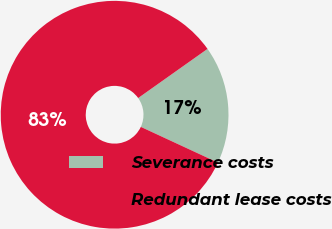Convert chart to OTSL. <chart><loc_0><loc_0><loc_500><loc_500><pie_chart><fcel>Severance costs<fcel>Redundant lease costs<nl><fcel>16.72%<fcel>83.28%<nl></chart> 